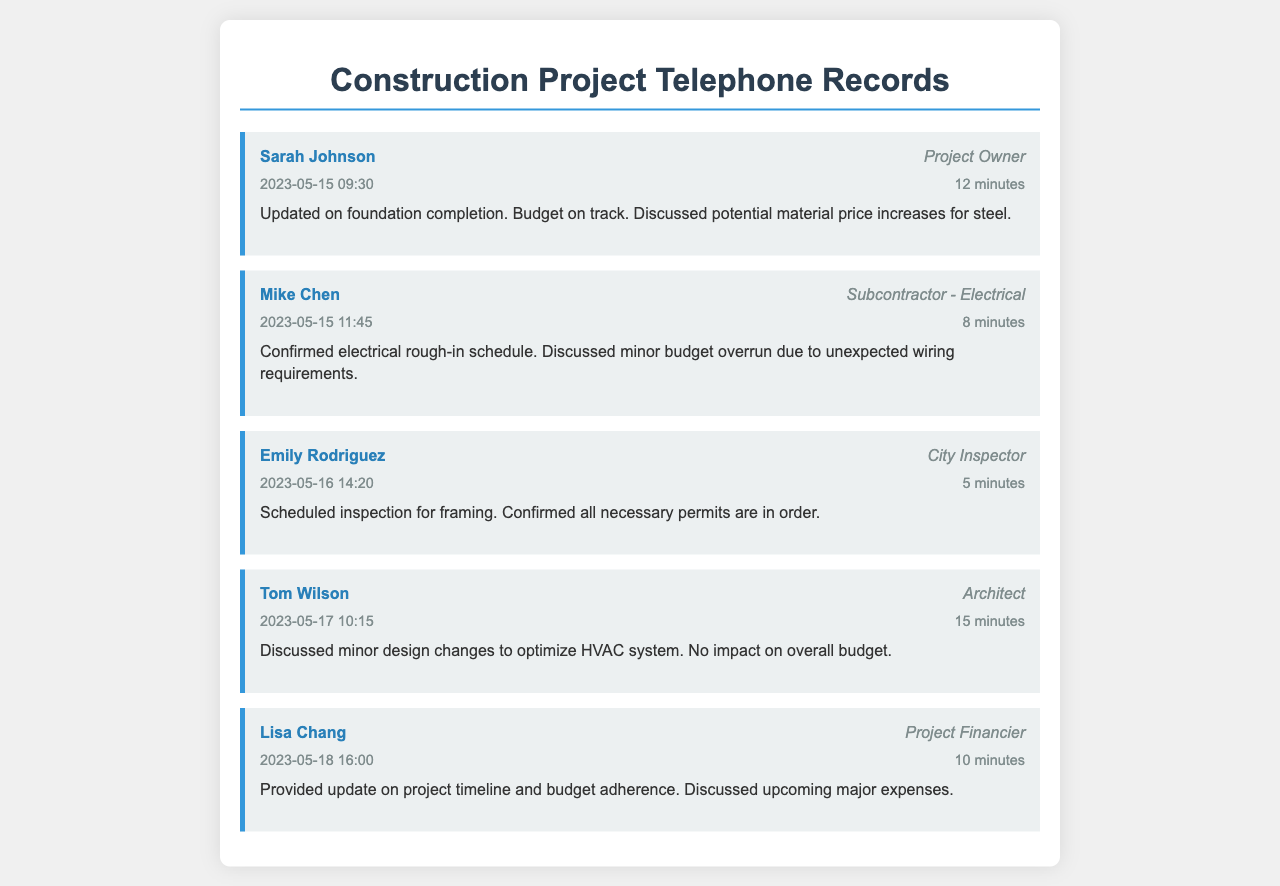What is the date of the call with Sarah Johnson? The date of the call with Sarah Johnson is specified as May 15, 2023.
Answer: May 15, 2023 How long was the call with Mike Chen? The duration of the call with Mike Chen is noted as 8 minutes.
Answer: 8 minutes What topic was discussed during the call with Emily Rodriguez? The primary topic of the call with Emily Rodriguez involved scheduling an inspection for framing.
Answer: Inspection for framing Who is the project financier? The individual identified as the project financier is Lisa Chang.
Answer: Lisa Chang What was the status of the budget during the call with Sarah Johnson? During the call with Sarah Johnson, it was mentioned that the budget is on track.
Answer: On track What were the minor issues discussed with Mike Chen? Mike Chen discussed a minor budget overrun due to unexpected wiring requirements.
Answer: Minor budget overrun How many minutes was the call with Tom Wilson? The call with Tom Wilson lasted for 15 minutes.
Answer: 15 minutes Was there any overall budget impact due to changes discussed with Tom Wilson? It was confirmed that there was no impact on the overall budget due to the changes discussed with Tom Wilson.
Answer: No impact When did the call with Lisa Chang take place? The call with Lisa Chang occurred on May 18, 2023.
Answer: May 18, 2023 